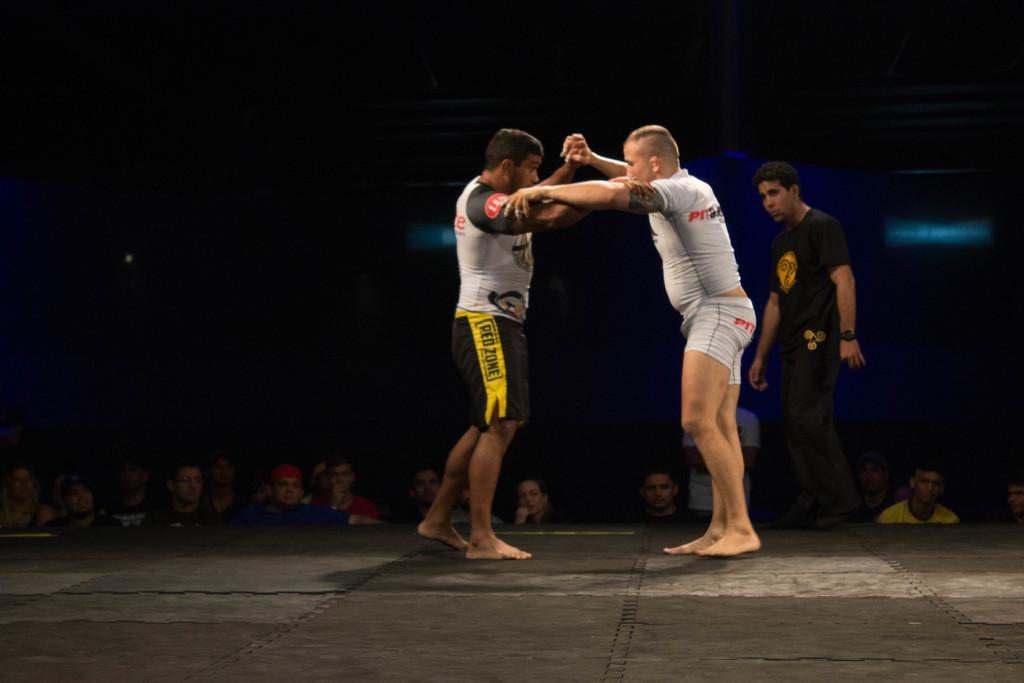Can you describe this image briefly? In the picture we can see two people are wrestling and one man is standing and watching and in the background, we can see some people are standing and watching them. 